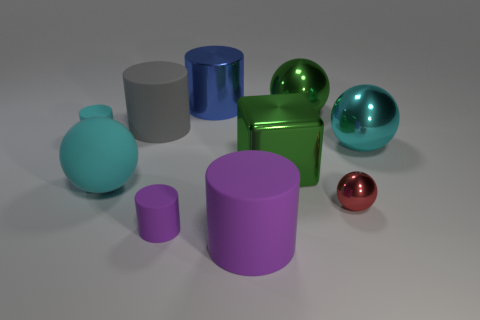There is a object that is the same color as the large metallic cube; what size is it?
Give a very brief answer. Large. How many other things are the same size as the blue cylinder?
Give a very brief answer. 6. How big is the ball that is right of the large blue thing and in front of the big cube?
Provide a succinct answer. Small. What number of green objects are the same shape as the red object?
Provide a succinct answer. 1. What material is the cyan cylinder?
Your answer should be compact. Rubber. Does the small purple thing have the same shape as the cyan metal object?
Your response must be concise. No. Are there any big green things that have the same material as the big blue thing?
Provide a succinct answer. Yes. What is the color of the sphere that is both behind the big cyan matte sphere and left of the large cyan shiny ball?
Offer a very short reply. Green. What material is the small thing right of the large blue metallic object?
Make the answer very short. Metal. Are there any brown rubber objects that have the same shape as the cyan metallic object?
Give a very brief answer. No. 